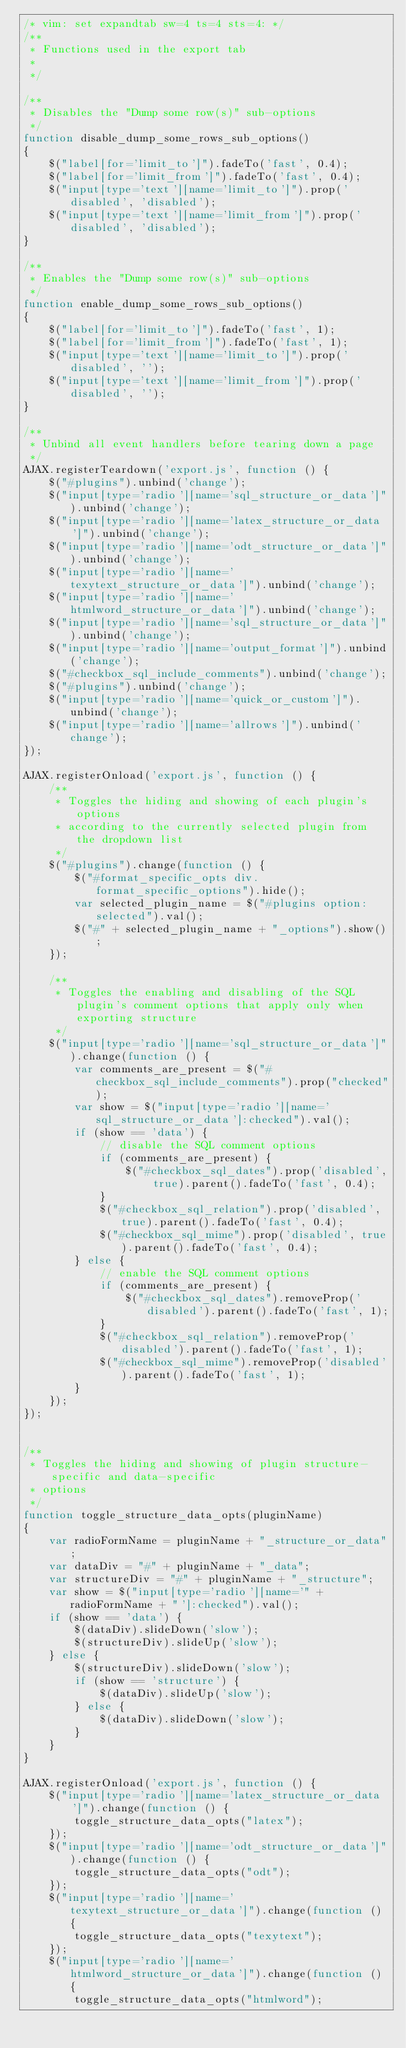Convert code to text. <code><loc_0><loc_0><loc_500><loc_500><_JavaScript_>/* vim: set expandtab sw=4 ts=4 sts=4: */
/**
 * Functions used in the export tab
 *
 */

/**
 * Disables the "Dump some row(s)" sub-options
 */
function disable_dump_some_rows_sub_options()
{
    $("label[for='limit_to']").fadeTo('fast', 0.4);
    $("label[for='limit_from']").fadeTo('fast', 0.4);
    $("input[type='text'][name='limit_to']").prop('disabled', 'disabled');
    $("input[type='text'][name='limit_from']").prop('disabled', 'disabled');
}

/**
 * Enables the "Dump some row(s)" sub-options
 */
function enable_dump_some_rows_sub_options()
{
    $("label[for='limit_to']").fadeTo('fast', 1);
    $("label[for='limit_from']").fadeTo('fast', 1);
    $("input[type='text'][name='limit_to']").prop('disabled', '');
    $("input[type='text'][name='limit_from']").prop('disabled', '');
}

/**
 * Unbind all event handlers before tearing down a page
 */
AJAX.registerTeardown('export.js', function () {
    $("#plugins").unbind('change');
    $("input[type='radio'][name='sql_structure_or_data']").unbind('change');
    $("input[type='radio'][name='latex_structure_or_data']").unbind('change');
    $("input[type='radio'][name='odt_structure_or_data']").unbind('change');
    $("input[type='radio'][name='texytext_structure_or_data']").unbind('change');
    $("input[type='radio'][name='htmlword_structure_or_data']").unbind('change');
    $("input[type='radio'][name='sql_structure_or_data']").unbind('change');
    $("input[type='radio'][name='output_format']").unbind('change');
    $("#checkbox_sql_include_comments").unbind('change');
    $("#plugins").unbind('change');
    $("input[type='radio'][name='quick_or_custom']").unbind('change');
    $("input[type='radio'][name='allrows']").unbind('change');
});

AJAX.registerOnload('export.js', function () {
    /**
     * Toggles the hiding and showing of each plugin's options
     * according to the currently selected plugin from the dropdown list
     */
    $("#plugins").change(function () {
        $("#format_specific_opts div.format_specific_options").hide();
        var selected_plugin_name = $("#plugins option:selected").val();
        $("#" + selected_plugin_name + "_options").show();
    });

    /**
     * Toggles the enabling and disabling of the SQL plugin's comment options that apply only when exporting structure
     */
    $("input[type='radio'][name='sql_structure_or_data']").change(function () {
        var comments_are_present = $("#checkbox_sql_include_comments").prop("checked");
        var show = $("input[type='radio'][name='sql_structure_or_data']:checked").val();
        if (show == 'data') {
            // disable the SQL comment options
            if (comments_are_present) {
                $("#checkbox_sql_dates").prop('disabled', true).parent().fadeTo('fast', 0.4);
            }
            $("#checkbox_sql_relation").prop('disabled', true).parent().fadeTo('fast', 0.4);
            $("#checkbox_sql_mime").prop('disabled', true).parent().fadeTo('fast', 0.4);
        } else {
            // enable the SQL comment options
            if (comments_are_present) {
                $("#checkbox_sql_dates").removeProp('disabled').parent().fadeTo('fast', 1);
            }
            $("#checkbox_sql_relation").removeProp('disabled').parent().fadeTo('fast', 1);
            $("#checkbox_sql_mime").removeProp('disabled').parent().fadeTo('fast', 1);
        }
    });
});


/**
 * Toggles the hiding and showing of plugin structure-specific and data-specific
 * options
 */
function toggle_structure_data_opts(pluginName)
{
    var radioFormName = pluginName + "_structure_or_data";
    var dataDiv = "#" + pluginName + "_data";
    var structureDiv = "#" + pluginName + "_structure";
    var show = $("input[type='radio'][name='" + radioFormName + "']:checked").val();
    if (show == 'data') {
        $(dataDiv).slideDown('slow');
        $(structureDiv).slideUp('slow');
    } else {
        $(structureDiv).slideDown('slow');
        if (show == 'structure') {
            $(dataDiv).slideUp('slow');
        } else {
            $(dataDiv).slideDown('slow');
        }
    }
}

AJAX.registerOnload('export.js', function () {
    $("input[type='radio'][name='latex_structure_or_data']").change(function () {
        toggle_structure_data_opts("latex");
    });
    $("input[type='radio'][name='odt_structure_or_data']").change(function () {
        toggle_structure_data_opts("odt");
    });
    $("input[type='radio'][name='texytext_structure_or_data']").change(function () {
        toggle_structure_data_opts("texytext");
    });
    $("input[type='radio'][name='htmlword_structure_or_data']").change(function () {
        toggle_structure_data_opts("htmlword");</code> 